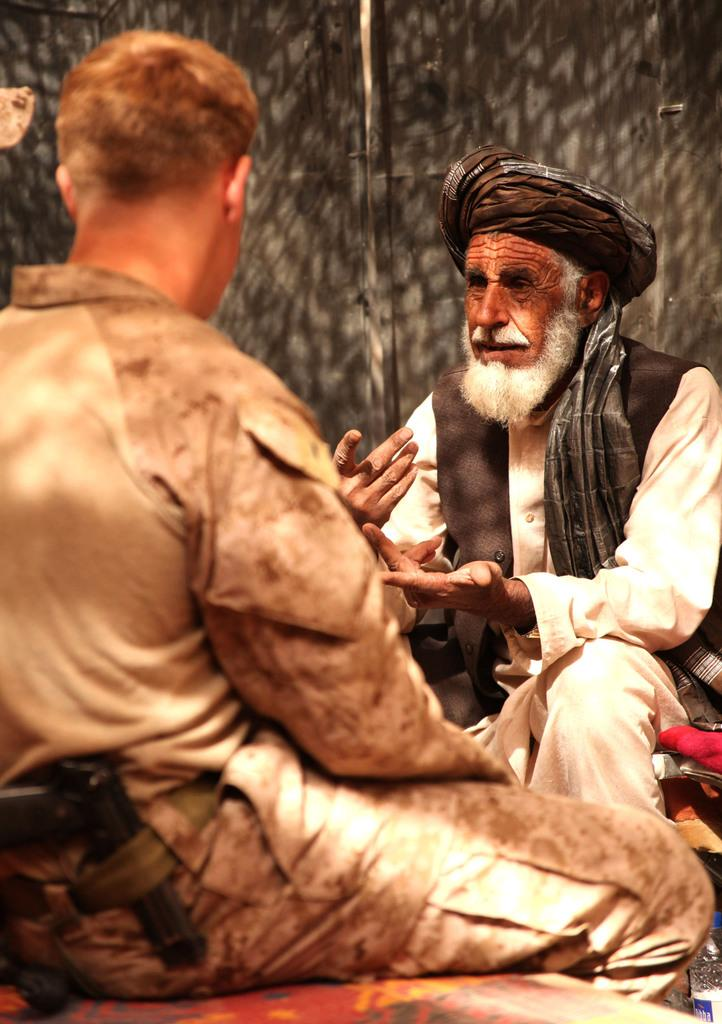What is the main subject of the image? The main subject of the image is a person with a gun. What is the person with the gun doing? The person with the gun is sitting on a surface. Who is present in front of the person with the gun? There is another person sitting and speaking in front of the person with the gun. Can you describe the background of the image? The background of the image is blurred. What type of dinosaur can be seen in the image? There are no dinosaurs present in the image. What kind of test is being conducted in the image? There is no test being conducted in the image. 